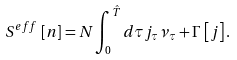<formula> <loc_0><loc_0><loc_500><loc_500>S ^ { e f f } \, \left [ n \right ] = N \int _ { 0 } ^ { \hat { T } } d \tau j _ { \tau } { \nu } _ { \tau } + \Gamma \, \left [ j \right ] .</formula> 